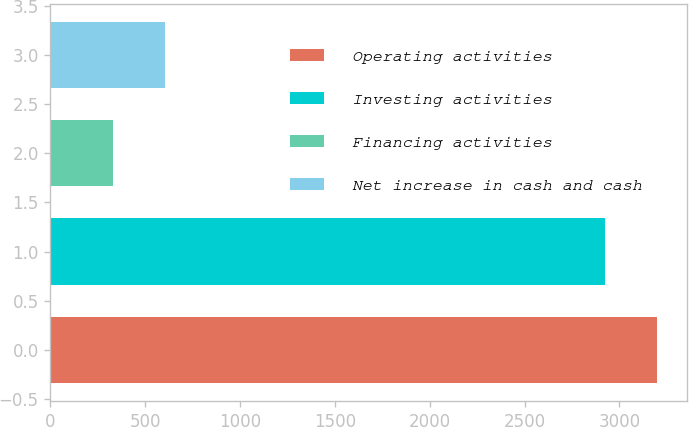Convert chart to OTSL. <chart><loc_0><loc_0><loc_500><loc_500><bar_chart><fcel>Operating activities<fcel>Investing activities<fcel>Financing activities<fcel>Net increase in cash and cash<nl><fcel>3195.4<fcel>2924<fcel>332<fcel>603.4<nl></chart> 